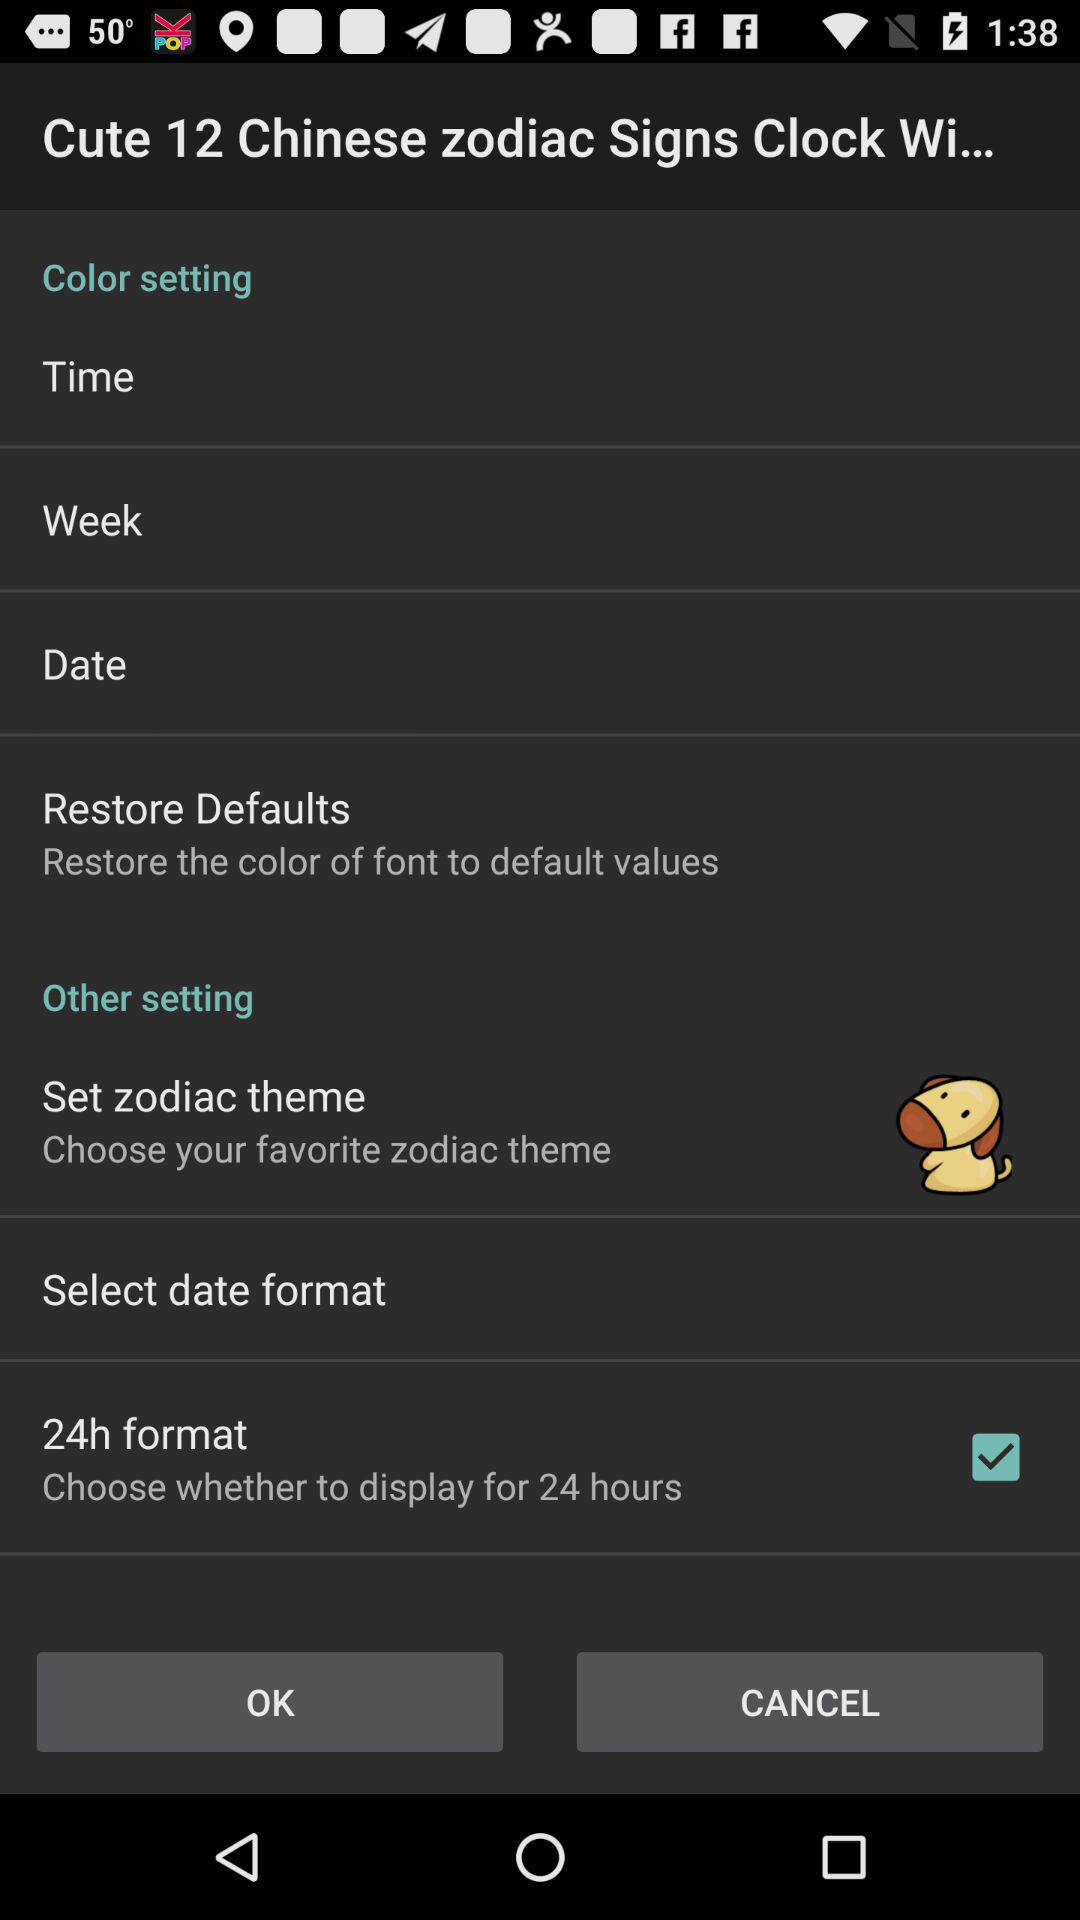What is the status of the "24h format" setting? The status of the "24h format" setting is "on". 